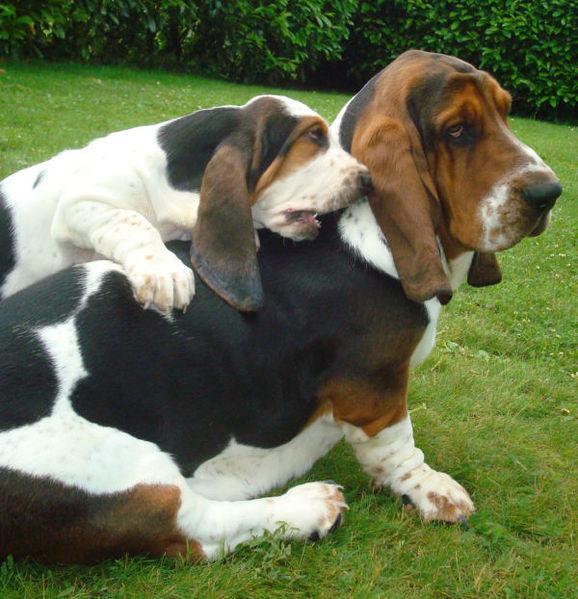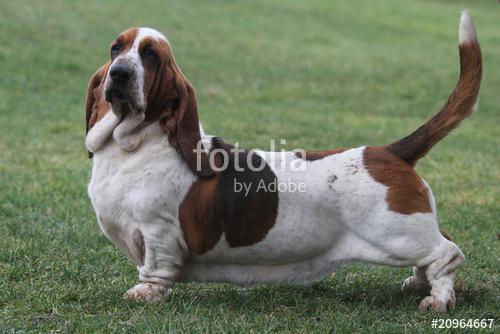The first image is the image on the left, the second image is the image on the right. Given the left and right images, does the statement "In one image there is a lone basset hound standing outside facing the left side of the image." hold true? Answer yes or no. Yes. The first image is the image on the left, the second image is the image on the right. For the images displayed, is the sentence "One dog is standing by itself with its tail up in the air." factually correct? Answer yes or no. Yes. 